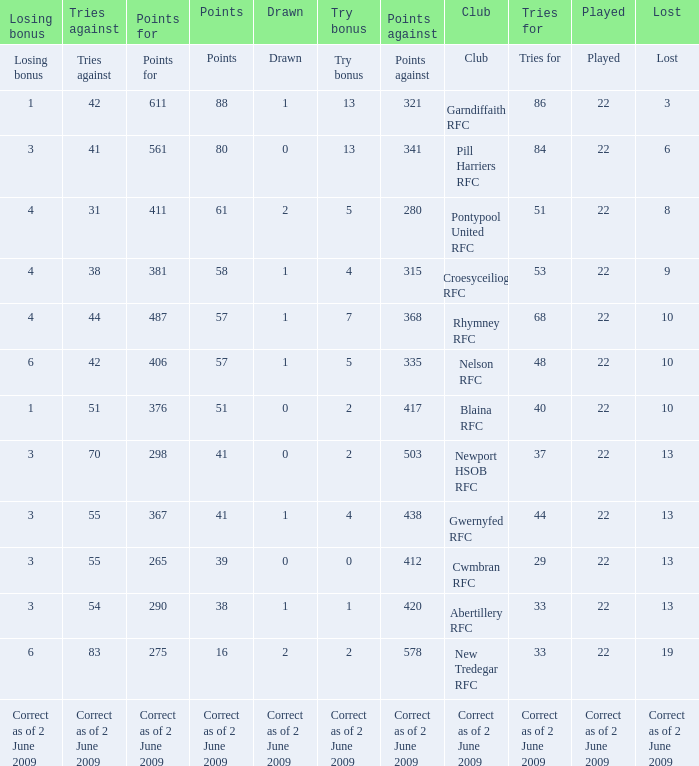Which club has 275 points? New Tredegar RFC. 